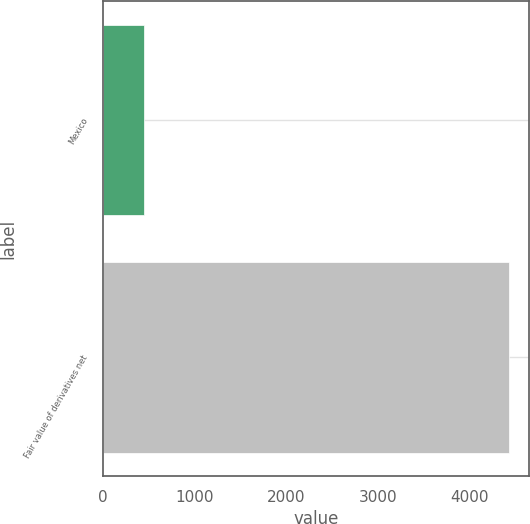Convert chart. <chart><loc_0><loc_0><loc_500><loc_500><bar_chart><fcel>Mexico<fcel>Fair value of derivatives net<nl><fcel>451<fcel>4432<nl></chart> 